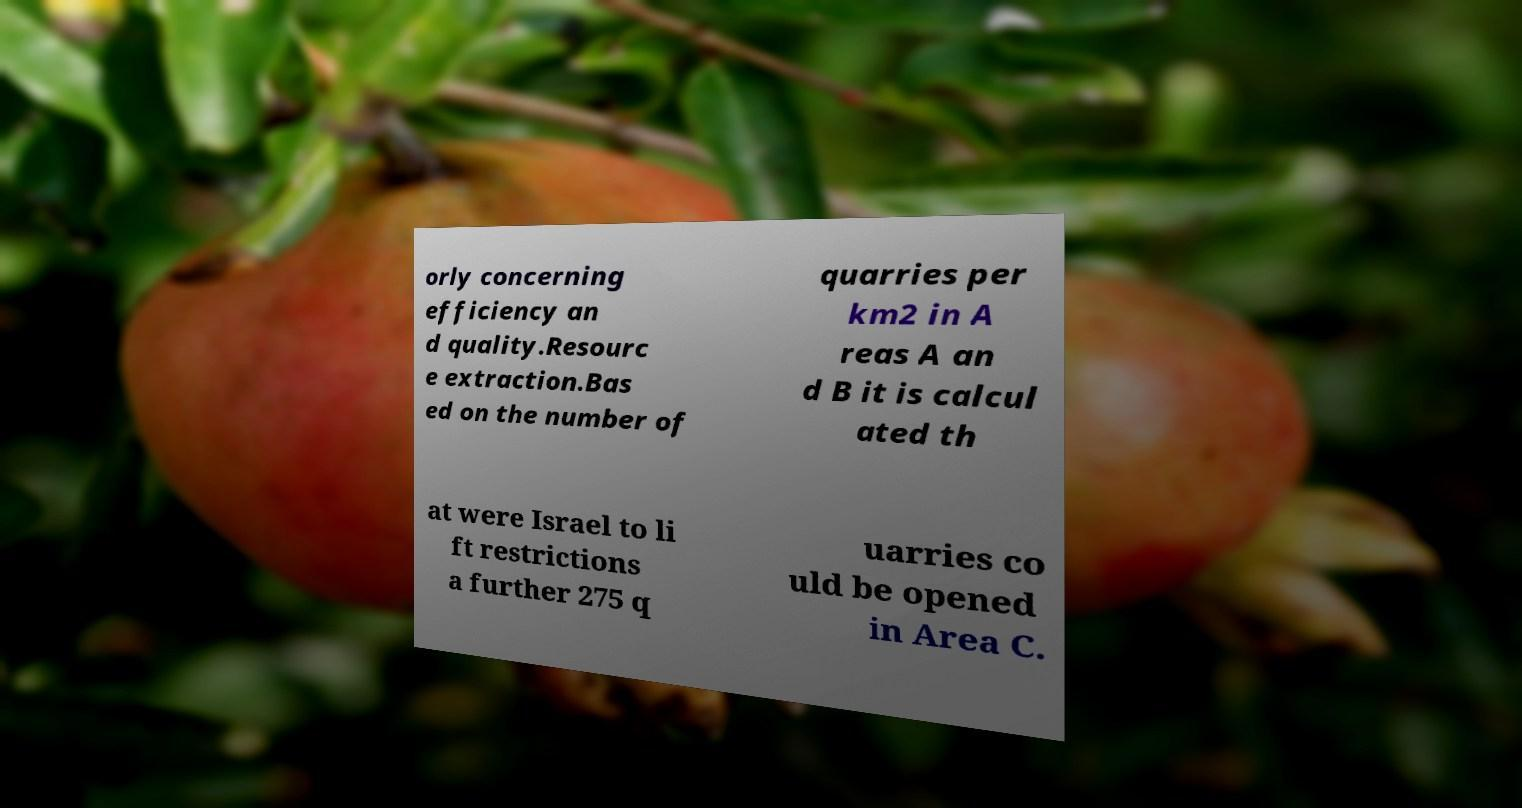There's text embedded in this image that I need extracted. Can you transcribe it verbatim? orly concerning efficiency an d quality.Resourc e extraction.Bas ed on the number of quarries per km2 in A reas A an d B it is calcul ated th at were Israel to li ft restrictions a further 275 q uarries co uld be opened in Area C. 